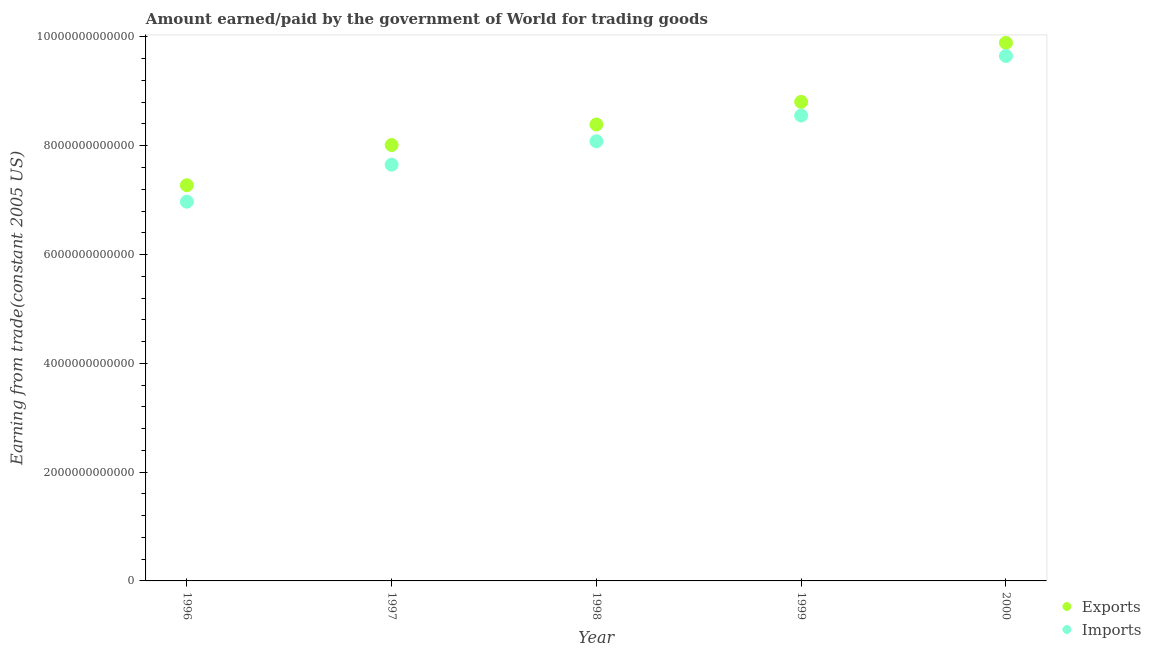What is the amount paid for imports in 1997?
Give a very brief answer. 7.65e+12. Across all years, what is the maximum amount paid for imports?
Make the answer very short. 9.65e+12. Across all years, what is the minimum amount earned from exports?
Your answer should be compact. 7.27e+12. In which year was the amount paid for imports maximum?
Provide a short and direct response. 2000. What is the total amount earned from exports in the graph?
Ensure brevity in your answer.  4.24e+13. What is the difference between the amount paid for imports in 1996 and that in 2000?
Your answer should be compact. -2.68e+12. What is the difference between the amount earned from exports in 1997 and the amount paid for imports in 2000?
Your response must be concise. -1.64e+12. What is the average amount earned from exports per year?
Your response must be concise. 8.48e+12. In the year 2000, what is the difference between the amount earned from exports and amount paid for imports?
Offer a very short reply. 2.42e+11. What is the ratio of the amount paid for imports in 1996 to that in 1999?
Provide a succinct answer. 0.81. Is the amount earned from exports in 1997 less than that in 1999?
Give a very brief answer. Yes. What is the difference between the highest and the second highest amount paid for imports?
Your response must be concise. 1.10e+12. What is the difference between the highest and the lowest amount earned from exports?
Offer a terse response. 2.62e+12. In how many years, is the amount earned from exports greater than the average amount earned from exports taken over all years?
Your answer should be very brief. 2. Is the sum of the amount earned from exports in 1996 and 1999 greater than the maximum amount paid for imports across all years?
Provide a succinct answer. Yes. Does the amount earned from exports monotonically increase over the years?
Your answer should be very brief. Yes. Is the amount paid for imports strictly less than the amount earned from exports over the years?
Offer a very short reply. Yes. How many dotlines are there?
Make the answer very short. 2. What is the difference between two consecutive major ticks on the Y-axis?
Your response must be concise. 2.00e+12. Does the graph contain any zero values?
Provide a succinct answer. No. What is the title of the graph?
Give a very brief answer. Amount earned/paid by the government of World for trading goods. Does "By country of origin" appear as one of the legend labels in the graph?
Your answer should be compact. No. What is the label or title of the X-axis?
Provide a succinct answer. Year. What is the label or title of the Y-axis?
Your answer should be very brief. Earning from trade(constant 2005 US). What is the Earning from trade(constant 2005 US) of Exports in 1996?
Offer a very short reply. 7.27e+12. What is the Earning from trade(constant 2005 US) in Imports in 1996?
Your response must be concise. 6.97e+12. What is the Earning from trade(constant 2005 US) in Exports in 1997?
Make the answer very short. 8.01e+12. What is the Earning from trade(constant 2005 US) of Imports in 1997?
Provide a succinct answer. 7.65e+12. What is the Earning from trade(constant 2005 US) in Exports in 1998?
Your response must be concise. 8.39e+12. What is the Earning from trade(constant 2005 US) of Imports in 1998?
Your response must be concise. 8.08e+12. What is the Earning from trade(constant 2005 US) of Exports in 1999?
Your answer should be compact. 8.81e+12. What is the Earning from trade(constant 2005 US) of Imports in 1999?
Your answer should be very brief. 8.55e+12. What is the Earning from trade(constant 2005 US) in Exports in 2000?
Provide a short and direct response. 9.89e+12. What is the Earning from trade(constant 2005 US) of Imports in 2000?
Ensure brevity in your answer.  9.65e+12. Across all years, what is the maximum Earning from trade(constant 2005 US) of Exports?
Your response must be concise. 9.89e+12. Across all years, what is the maximum Earning from trade(constant 2005 US) of Imports?
Make the answer very short. 9.65e+12. Across all years, what is the minimum Earning from trade(constant 2005 US) in Exports?
Your response must be concise. 7.27e+12. Across all years, what is the minimum Earning from trade(constant 2005 US) in Imports?
Make the answer very short. 6.97e+12. What is the total Earning from trade(constant 2005 US) of Exports in the graph?
Your answer should be very brief. 4.24e+13. What is the total Earning from trade(constant 2005 US) in Imports in the graph?
Provide a succinct answer. 4.09e+13. What is the difference between the Earning from trade(constant 2005 US) of Exports in 1996 and that in 1997?
Your answer should be very brief. -7.39e+11. What is the difference between the Earning from trade(constant 2005 US) in Imports in 1996 and that in 1997?
Provide a short and direct response. -6.80e+11. What is the difference between the Earning from trade(constant 2005 US) of Exports in 1996 and that in 1998?
Provide a short and direct response. -1.12e+12. What is the difference between the Earning from trade(constant 2005 US) in Imports in 1996 and that in 1998?
Make the answer very short. -1.11e+12. What is the difference between the Earning from trade(constant 2005 US) of Exports in 1996 and that in 1999?
Offer a terse response. -1.53e+12. What is the difference between the Earning from trade(constant 2005 US) of Imports in 1996 and that in 1999?
Provide a short and direct response. -1.58e+12. What is the difference between the Earning from trade(constant 2005 US) of Exports in 1996 and that in 2000?
Make the answer very short. -2.62e+12. What is the difference between the Earning from trade(constant 2005 US) in Imports in 1996 and that in 2000?
Provide a short and direct response. -2.68e+12. What is the difference between the Earning from trade(constant 2005 US) of Exports in 1997 and that in 1998?
Make the answer very short. -3.78e+11. What is the difference between the Earning from trade(constant 2005 US) of Imports in 1997 and that in 1998?
Offer a terse response. -4.30e+11. What is the difference between the Earning from trade(constant 2005 US) in Exports in 1997 and that in 1999?
Ensure brevity in your answer.  -7.94e+11. What is the difference between the Earning from trade(constant 2005 US) in Imports in 1997 and that in 1999?
Keep it short and to the point. -9.03e+11. What is the difference between the Earning from trade(constant 2005 US) in Exports in 1997 and that in 2000?
Your answer should be very brief. -1.88e+12. What is the difference between the Earning from trade(constant 2005 US) of Imports in 1997 and that in 2000?
Provide a succinct answer. -2.00e+12. What is the difference between the Earning from trade(constant 2005 US) in Exports in 1998 and that in 1999?
Offer a terse response. -4.16e+11. What is the difference between the Earning from trade(constant 2005 US) of Imports in 1998 and that in 1999?
Provide a succinct answer. -4.73e+11. What is the difference between the Earning from trade(constant 2005 US) in Exports in 1998 and that in 2000?
Offer a terse response. -1.50e+12. What is the difference between the Earning from trade(constant 2005 US) in Imports in 1998 and that in 2000?
Give a very brief answer. -1.57e+12. What is the difference between the Earning from trade(constant 2005 US) in Exports in 1999 and that in 2000?
Provide a succinct answer. -1.09e+12. What is the difference between the Earning from trade(constant 2005 US) in Imports in 1999 and that in 2000?
Your response must be concise. -1.10e+12. What is the difference between the Earning from trade(constant 2005 US) in Exports in 1996 and the Earning from trade(constant 2005 US) in Imports in 1997?
Make the answer very short. -3.78e+11. What is the difference between the Earning from trade(constant 2005 US) in Exports in 1996 and the Earning from trade(constant 2005 US) in Imports in 1998?
Offer a very short reply. -8.08e+11. What is the difference between the Earning from trade(constant 2005 US) of Exports in 1996 and the Earning from trade(constant 2005 US) of Imports in 1999?
Offer a very short reply. -1.28e+12. What is the difference between the Earning from trade(constant 2005 US) of Exports in 1996 and the Earning from trade(constant 2005 US) of Imports in 2000?
Your answer should be compact. -2.38e+12. What is the difference between the Earning from trade(constant 2005 US) in Exports in 1997 and the Earning from trade(constant 2005 US) in Imports in 1998?
Ensure brevity in your answer.  -6.88e+1. What is the difference between the Earning from trade(constant 2005 US) of Exports in 1997 and the Earning from trade(constant 2005 US) of Imports in 1999?
Give a very brief answer. -5.42e+11. What is the difference between the Earning from trade(constant 2005 US) in Exports in 1997 and the Earning from trade(constant 2005 US) in Imports in 2000?
Give a very brief answer. -1.64e+12. What is the difference between the Earning from trade(constant 2005 US) of Exports in 1998 and the Earning from trade(constant 2005 US) of Imports in 1999?
Keep it short and to the point. -1.64e+11. What is the difference between the Earning from trade(constant 2005 US) of Exports in 1998 and the Earning from trade(constant 2005 US) of Imports in 2000?
Your answer should be very brief. -1.26e+12. What is the difference between the Earning from trade(constant 2005 US) in Exports in 1999 and the Earning from trade(constant 2005 US) in Imports in 2000?
Your response must be concise. -8.44e+11. What is the average Earning from trade(constant 2005 US) in Exports per year?
Give a very brief answer. 8.48e+12. What is the average Earning from trade(constant 2005 US) in Imports per year?
Offer a very short reply. 8.18e+12. In the year 1996, what is the difference between the Earning from trade(constant 2005 US) in Exports and Earning from trade(constant 2005 US) in Imports?
Ensure brevity in your answer.  3.02e+11. In the year 1997, what is the difference between the Earning from trade(constant 2005 US) in Exports and Earning from trade(constant 2005 US) in Imports?
Provide a succinct answer. 3.61e+11. In the year 1998, what is the difference between the Earning from trade(constant 2005 US) in Exports and Earning from trade(constant 2005 US) in Imports?
Your answer should be compact. 3.09e+11. In the year 1999, what is the difference between the Earning from trade(constant 2005 US) in Exports and Earning from trade(constant 2005 US) in Imports?
Your answer should be compact. 2.52e+11. In the year 2000, what is the difference between the Earning from trade(constant 2005 US) of Exports and Earning from trade(constant 2005 US) of Imports?
Your response must be concise. 2.42e+11. What is the ratio of the Earning from trade(constant 2005 US) in Exports in 1996 to that in 1997?
Provide a short and direct response. 0.91. What is the ratio of the Earning from trade(constant 2005 US) in Imports in 1996 to that in 1997?
Ensure brevity in your answer.  0.91. What is the ratio of the Earning from trade(constant 2005 US) in Exports in 1996 to that in 1998?
Offer a very short reply. 0.87. What is the ratio of the Earning from trade(constant 2005 US) in Imports in 1996 to that in 1998?
Give a very brief answer. 0.86. What is the ratio of the Earning from trade(constant 2005 US) of Exports in 1996 to that in 1999?
Offer a very short reply. 0.83. What is the ratio of the Earning from trade(constant 2005 US) of Imports in 1996 to that in 1999?
Provide a short and direct response. 0.81. What is the ratio of the Earning from trade(constant 2005 US) in Exports in 1996 to that in 2000?
Provide a short and direct response. 0.74. What is the ratio of the Earning from trade(constant 2005 US) of Imports in 1996 to that in 2000?
Provide a short and direct response. 0.72. What is the ratio of the Earning from trade(constant 2005 US) of Exports in 1997 to that in 1998?
Provide a succinct answer. 0.95. What is the ratio of the Earning from trade(constant 2005 US) of Imports in 1997 to that in 1998?
Your answer should be compact. 0.95. What is the ratio of the Earning from trade(constant 2005 US) of Exports in 1997 to that in 1999?
Your answer should be very brief. 0.91. What is the ratio of the Earning from trade(constant 2005 US) of Imports in 1997 to that in 1999?
Provide a short and direct response. 0.89. What is the ratio of the Earning from trade(constant 2005 US) in Exports in 1997 to that in 2000?
Your answer should be very brief. 0.81. What is the ratio of the Earning from trade(constant 2005 US) in Imports in 1997 to that in 2000?
Provide a succinct answer. 0.79. What is the ratio of the Earning from trade(constant 2005 US) in Exports in 1998 to that in 1999?
Ensure brevity in your answer.  0.95. What is the ratio of the Earning from trade(constant 2005 US) of Imports in 1998 to that in 1999?
Provide a succinct answer. 0.94. What is the ratio of the Earning from trade(constant 2005 US) of Exports in 1998 to that in 2000?
Provide a succinct answer. 0.85. What is the ratio of the Earning from trade(constant 2005 US) of Imports in 1998 to that in 2000?
Ensure brevity in your answer.  0.84. What is the ratio of the Earning from trade(constant 2005 US) in Exports in 1999 to that in 2000?
Make the answer very short. 0.89. What is the ratio of the Earning from trade(constant 2005 US) in Imports in 1999 to that in 2000?
Your response must be concise. 0.89. What is the difference between the highest and the second highest Earning from trade(constant 2005 US) in Exports?
Offer a terse response. 1.09e+12. What is the difference between the highest and the second highest Earning from trade(constant 2005 US) in Imports?
Offer a very short reply. 1.10e+12. What is the difference between the highest and the lowest Earning from trade(constant 2005 US) of Exports?
Ensure brevity in your answer.  2.62e+12. What is the difference between the highest and the lowest Earning from trade(constant 2005 US) of Imports?
Give a very brief answer. 2.68e+12. 